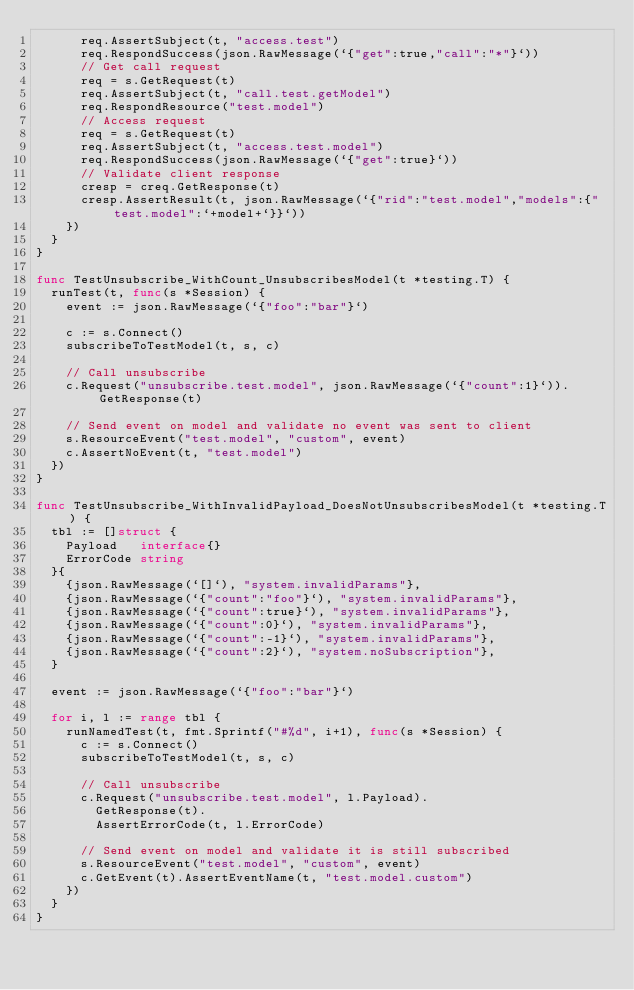<code> <loc_0><loc_0><loc_500><loc_500><_Go_>			req.AssertSubject(t, "access.test")
			req.RespondSuccess(json.RawMessage(`{"get":true,"call":"*"}`))
			// Get call request
			req = s.GetRequest(t)
			req.AssertSubject(t, "call.test.getModel")
			req.RespondResource("test.model")
			// Access request
			req = s.GetRequest(t)
			req.AssertSubject(t, "access.test.model")
			req.RespondSuccess(json.RawMessage(`{"get":true}`))
			// Validate client response
			cresp = creq.GetResponse(t)
			cresp.AssertResult(t, json.RawMessage(`{"rid":"test.model","models":{"test.model":`+model+`}}`))
		})
	}
}

func TestUnsubscribe_WithCount_UnsubscribesModel(t *testing.T) {
	runTest(t, func(s *Session) {
		event := json.RawMessage(`{"foo":"bar"}`)

		c := s.Connect()
		subscribeToTestModel(t, s, c)

		// Call unsubscribe
		c.Request("unsubscribe.test.model", json.RawMessage(`{"count":1}`)).GetResponse(t)

		// Send event on model and validate no event was sent to client
		s.ResourceEvent("test.model", "custom", event)
		c.AssertNoEvent(t, "test.model")
	})
}

func TestUnsubscribe_WithInvalidPayload_DoesNotUnsubscribesModel(t *testing.T) {
	tbl := []struct {
		Payload   interface{}
		ErrorCode string
	}{
		{json.RawMessage(`[]`), "system.invalidParams"},
		{json.RawMessage(`{"count":"foo"}`), "system.invalidParams"},
		{json.RawMessage(`{"count":true}`), "system.invalidParams"},
		{json.RawMessage(`{"count":0}`), "system.invalidParams"},
		{json.RawMessage(`{"count":-1}`), "system.invalidParams"},
		{json.RawMessage(`{"count":2}`), "system.noSubscription"},
	}

	event := json.RawMessage(`{"foo":"bar"}`)

	for i, l := range tbl {
		runNamedTest(t, fmt.Sprintf("#%d", i+1), func(s *Session) {
			c := s.Connect()
			subscribeToTestModel(t, s, c)

			// Call unsubscribe
			c.Request("unsubscribe.test.model", l.Payload).
				GetResponse(t).
				AssertErrorCode(t, l.ErrorCode)

			// Send event on model and validate it is still subscribed
			s.ResourceEvent("test.model", "custom", event)
			c.GetEvent(t).AssertEventName(t, "test.model.custom")
		})
	}
}
</code> 